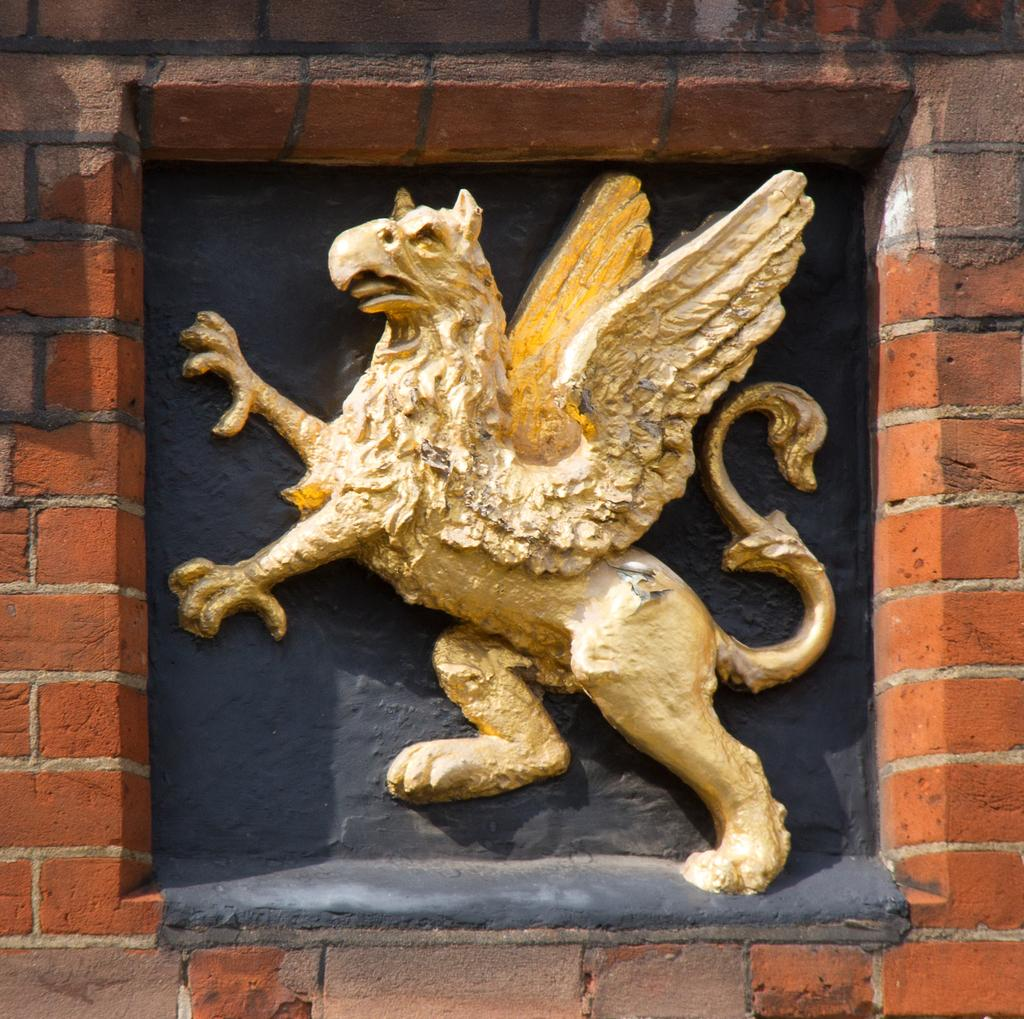What is the main subject in the image? There is a sculpture in the image. Where is the sculpture located? The sculpture is on the wall. What type of liquid is being poured from the sculpture in the image? There is no liquid being poured from the sculpture in the image; it is a stationary sculpture on the wall. 